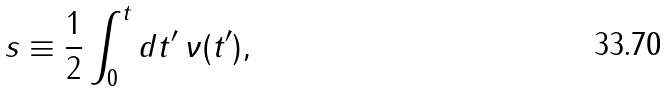<formula> <loc_0><loc_0><loc_500><loc_500>s \equiv \frac { 1 } { 2 } \int _ { 0 } ^ { t } d t ^ { \prime } \, \nu ( t ^ { \prime } ) ,</formula> 